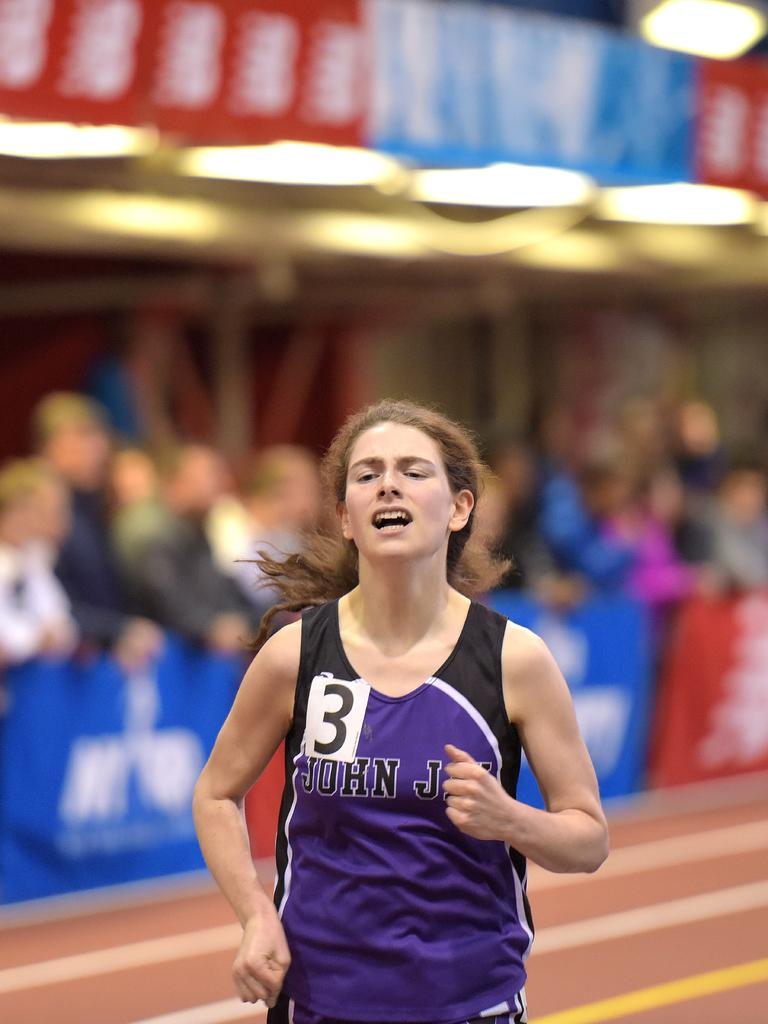Provide a one-sentence caption for the provided image. A female athlete's uniform contains the name John and the number 3. 